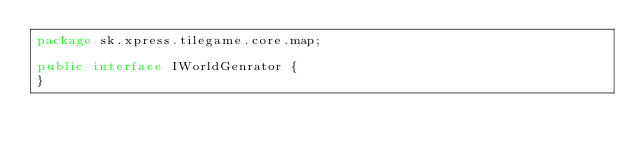<code> <loc_0><loc_0><loc_500><loc_500><_Java_>package sk.xpress.tilegame.core.map;

public interface IWorldGenrator {
}
</code> 